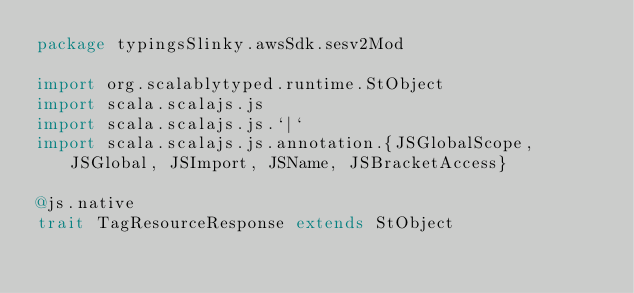<code> <loc_0><loc_0><loc_500><loc_500><_Scala_>package typingsSlinky.awsSdk.sesv2Mod

import org.scalablytyped.runtime.StObject
import scala.scalajs.js
import scala.scalajs.js.`|`
import scala.scalajs.js.annotation.{JSGlobalScope, JSGlobal, JSImport, JSName, JSBracketAccess}

@js.native
trait TagResourceResponse extends StObject
</code> 